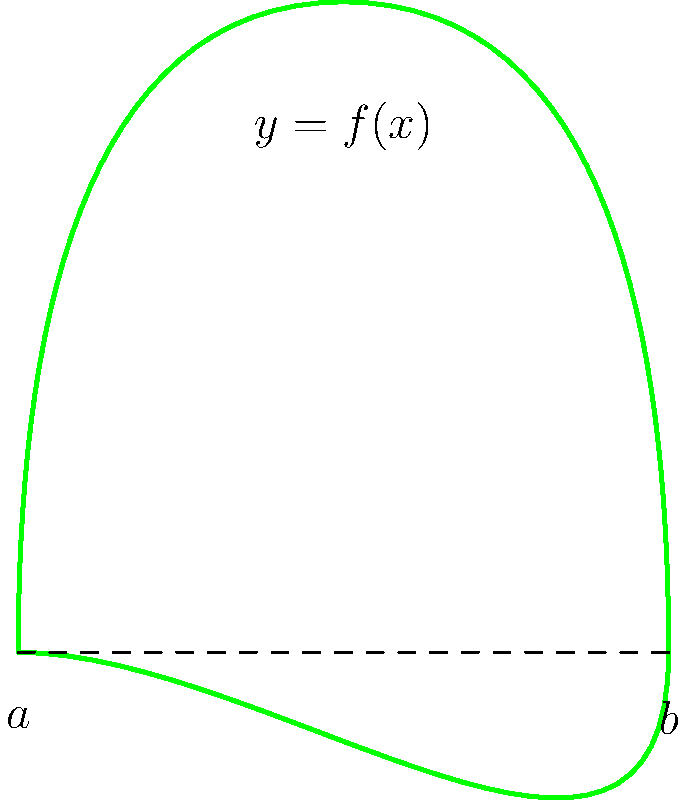As a herpetologist studying the surface area of frog skin, you've modeled the cross-section of a frog as a smooth curve $y = f(x)$ rotated about the x-axis. The curve extends from $x = a$ to $x = b$. Given that the surface area of a solid of revolution is given by the formula $S = 2\pi \int_a^b f(x) \sqrt{1 + [f'(x)]^2} dx$, express the surface area of the frog's skin in terms of $f(x)$, $a$, and $b$. To solve this problem, we'll follow these steps:

1) The formula for the surface area of a solid of revolution is given in the question:

   $S = 2\pi \int_a^b f(x) \sqrt{1 + [f'(x)]^2} dx$

2) This formula already includes all the components we need:
   - $f(x)$ represents the function describing the frog's cross-section
   - $a$ and $b$ are the limits of integration, representing the start and end points of the frog along the x-axis
   - $f'(x)$ is the derivative of $f(x)$, which is included in the square root term

3) We don't need to make any changes to this formula. It directly gives us the surface area of the frog's skin when rotated around the x-axis.

4) The final expression for the surface area is thus:

   $S = 2\pi \int_a^b f(x) \sqrt{1 + [f'(x)]^2} dx$

This formula allows us to calculate the surface area of the frog's skin given any specific function $f(x)$ and limits $a$ and $b$.
Answer: $S = 2\pi \int_a^b f(x) \sqrt{1 + [f'(x)]^2} dx$ 